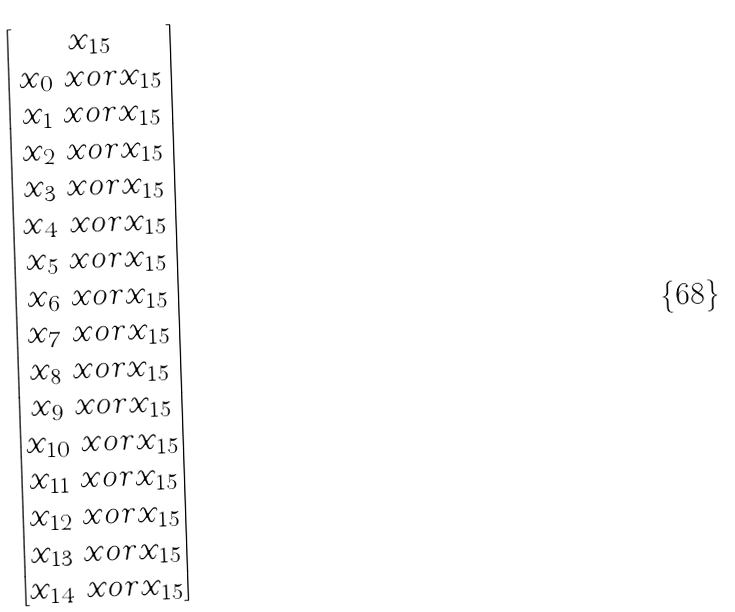<formula> <loc_0><loc_0><loc_500><loc_500>\begin{bmatrix} x _ { 1 5 } \\ x _ { 0 } \ x o r x _ { 1 5 } \\ x _ { 1 } \ x o r x _ { 1 5 } \\ x _ { 2 } \ x o r x _ { 1 5 } \\ x _ { 3 } \ x o r x _ { 1 5 } \\ x _ { 4 } \ x o r x _ { 1 5 } \\ x _ { 5 } \ x o r x _ { 1 5 } \\ x _ { 6 } \ x o r x _ { 1 5 } \\ x _ { 7 } \ x o r x _ { 1 5 } \\ x _ { 8 } \ x o r x _ { 1 5 } \\ x _ { 9 } \ x o r x _ { 1 5 } \\ x _ { 1 0 } \ x o r x _ { 1 5 } \\ x _ { 1 1 } \ x o r x _ { 1 5 } \\ x _ { 1 2 } \ x o r x _ { 1 5 } \\ x _ { 1 3 } \ x o r x _ { 1 5 } \\ x _ { 1 4 } \ x o r x _ { 1 5 } \end{bmatrix}</formula> 